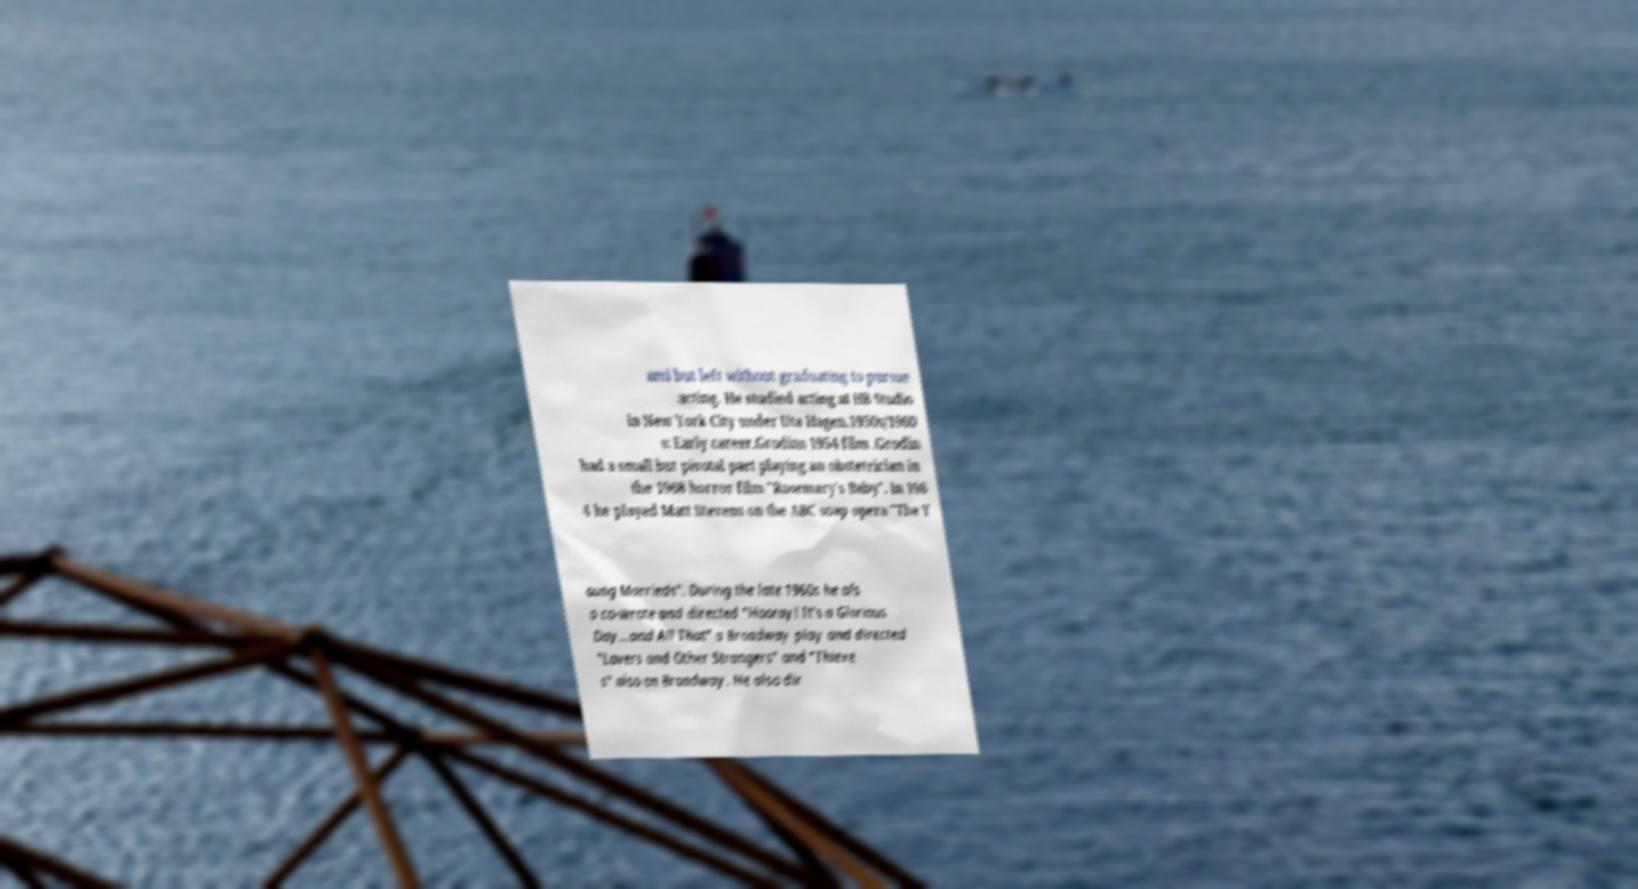There's text embedded in this image that I need extracted. Can you transcribe it verbatim? ami but left without graduating to pursue acting. He studied acting at HB Studio in New York City under Uta Hagen.1950s/1960 s: Early career.Grodins 1954 film .Grodin had a small but pivotal part playing an obstetrician in the 1968 horror film "Rosemary's Baby". In 196 4 he played Matt Stevens on the ABC soap opera "The Y oung Marrieds". During the late 1960s he als o co-wrote and directed "Hooray! It's a Glorious Day...and All That" a Broadway play and directed "Lovers and Other Strangers" and "Thieve s" also on Broadway. He also dir 